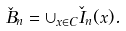Convert formula to latex. <formula><loc_0><loc_0><loc_500><loc_500>\check { B } _ { n } = \cup _ { x \in C } \check { I } _ { n } ( x ) .</formula> 